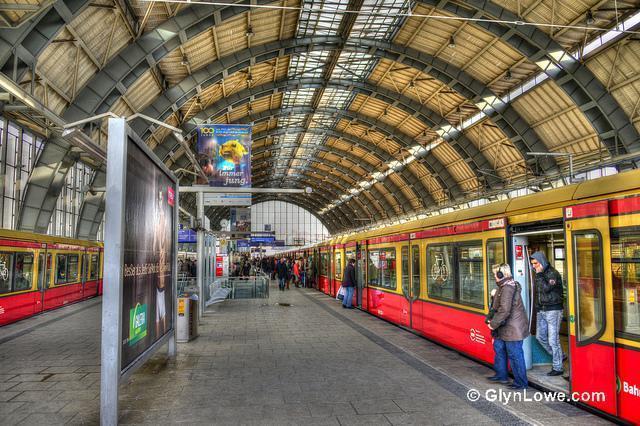How many people can you see?
Give a very brief answer. 2. How many trains are there?
Give a very brief answer. 2. 